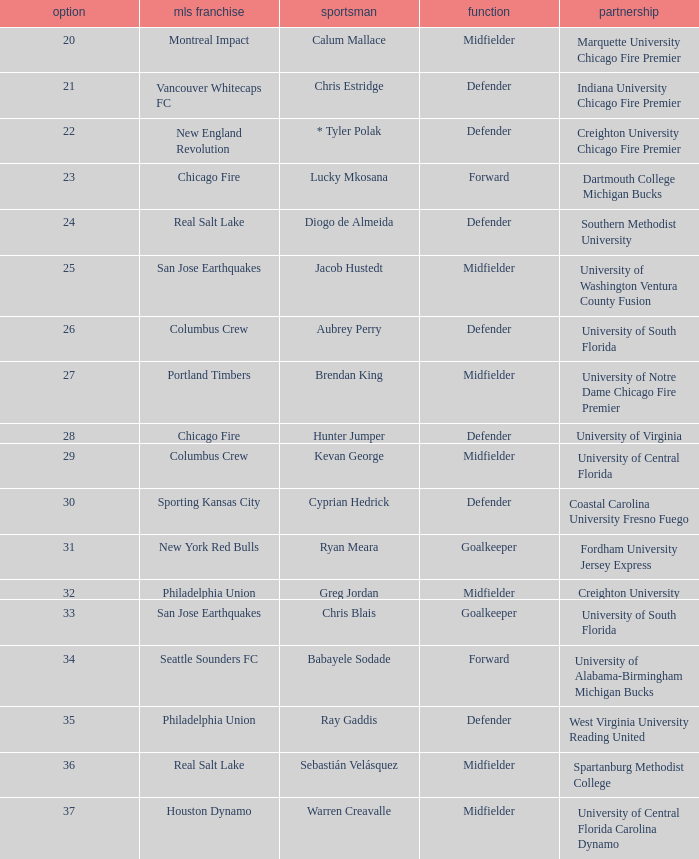What university was Kevan George affiliated with? University of Central Florida. 